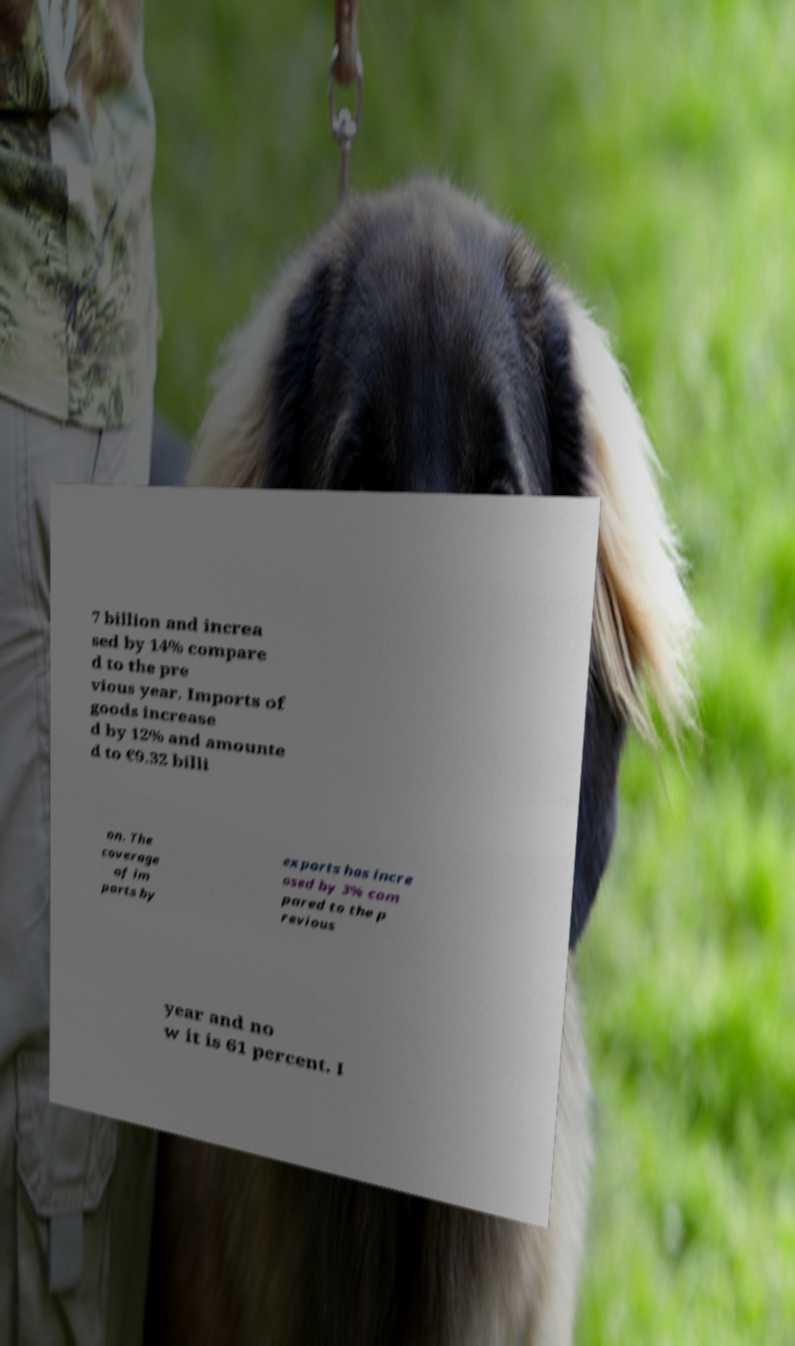For documentation purposes, I need the text within this image transcribed. Could you provide that? 7 billion and increa sed by 14% compare d to the pre vious year. Imports of goods increase d by 12% and amounte d to €9.32 billi on. The coverage of im ports by exports has incre ased by 3% com pared to the p revious year and no w it is 61 percent. I 